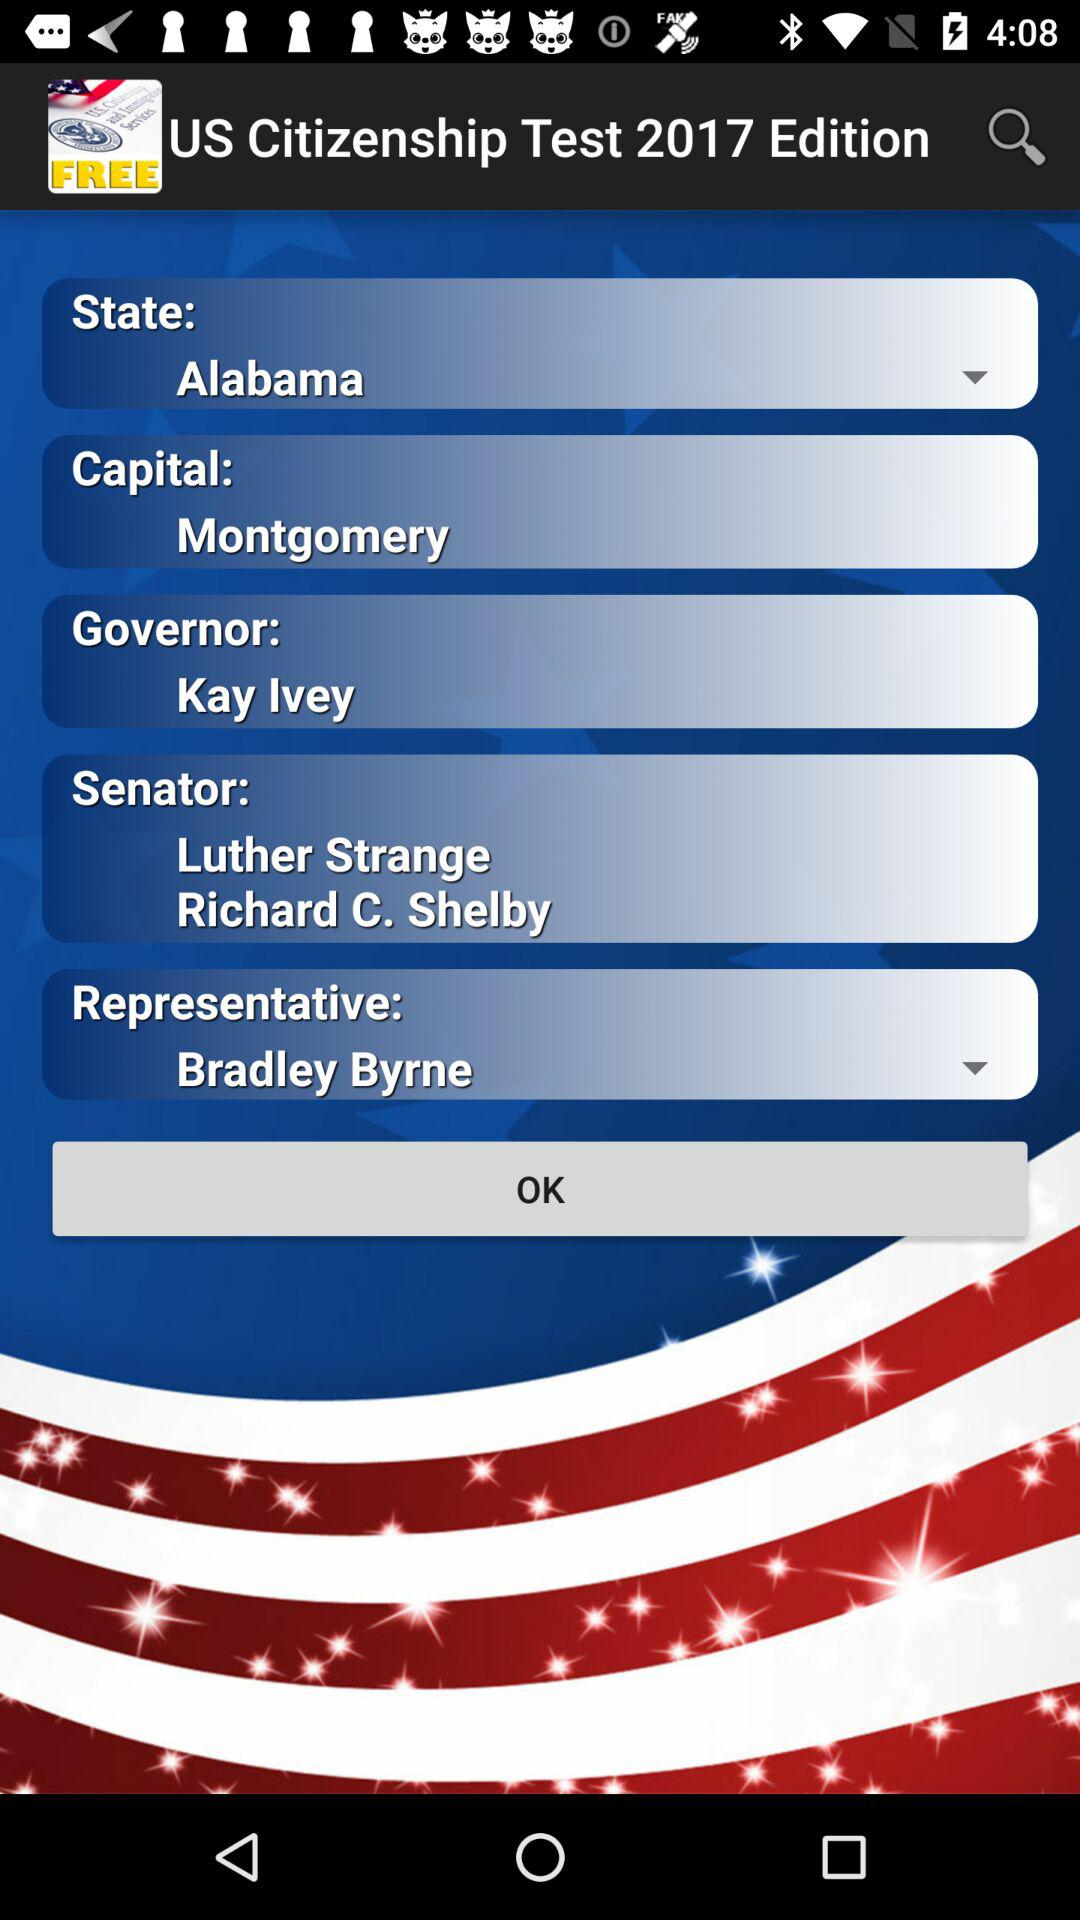Who is the representative? The representative is Bradley Byrne. 